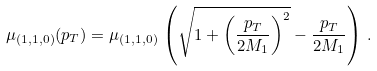Convert formula to latex. <formula><loc_0><loc_0><loc_500><loc_500>\mu _ { ( 1 , 1 , 0 ) } ( p _ { T } ) = \mu _ { ( 1 , 1 , 0 ) } \, \left ( \sqrt { 1 + \left ( \frac { p _ { T } } { 2 M _ { 1 } } \right ) ^ { 2 } } - \frac { p _ { T } } { 2 M _ { 1 } } \right ) \, .</formula> 